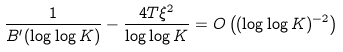Convert formula to latex. <formula><loc_0><loc_0><loc_500><loc_500>\frac { 1 } { B ^ { \prime } ( \log \log K ) } - \frac { 4 T \xi ^ { 2 } } { \log \log K } = O \left ( ( \log \log K ) ^ { - 2 } \right )</formula> 